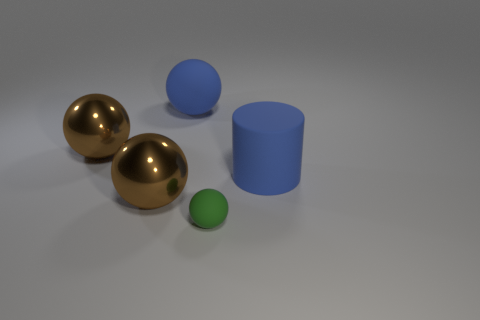Subtract all big blue matte spheres. How many spheres are left? 3 Subtract all green balls. How many balls are left? 3 Subtract all yellow cylinders. How many brown spheres are left? 2 Add 1 matte spheres. How many objects exist? 6 Subtract all spheres. How many objects are left? 1 Subtract 1 cylinders. How many cylinders are left? 0 Subtract 2 brown balls. How many objects are left? 3 Subtract all brown cylinders. Subtract all blue balls. How many cylinders are left? 1 Subtract all green matte things. Subtract all matte cylinders. How many objects are left? 3 Add 4 spheres. How many spheres are left? 8 